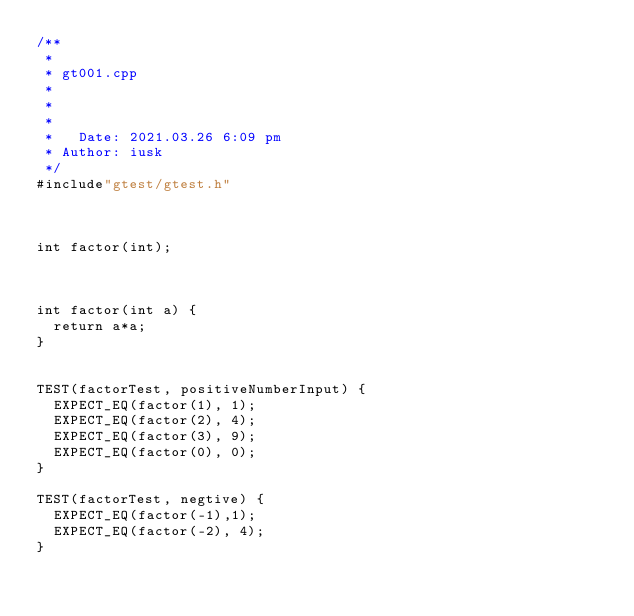<code> <loc_0><loc_0><loc_500><loc_500><_C++_>/**
 *
 * gt001.cpp
 *
 *
 *
 *   Date: 2021.03.26 6:09 pm
 * Author: iusk
 */
#include"gtest/gtest.h"



int factor(int);



int factor(int a) {
	return a*a;
}


TEST(factorTest, positiveNumberInput) {
	EXPECT_EQ(factor(1), 1);
	EXPECT_EQ(factor(2), 4);
	EXPECT_EQ(factor(3), 9);
	EXPECT_EQ(factor(0), 0);
}

TEST(factorTest, negtive) {
	EXPECT_EQ(factor(-1),1);
	EXPECT_EQ(factor(-2), 4);
}

</code> 